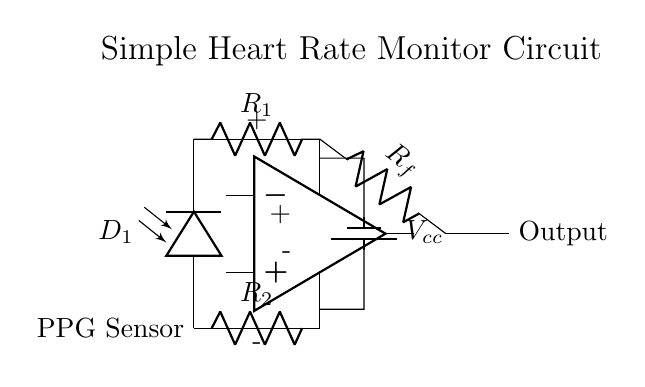What is the type of circuit represented? This is an analog circuit, specifically a heart rate monitor circuit that uses a photoplethysmography sensor and an operational amplifier. Analog circuits are characterized by continuous signal variations, which is suitable for monitoring physiological signals like heart rate.
Answer: analog circuit What component is used for detecting the heart rate? The component used for detecting the heart rate in this circuit is the photoplethysmography sensor (PPG), which is represented as D1 in the diagram. PPG sensors detect changes in light absorption due to blood volume changes in the microvascular bed of tissue.
Answer: PPG sensor What does the output of the circuit represent? The output of the circuit represents the amplified signal corresponding to the heart rate detected by the photoplethysmography sensor. The operational amplifier amplifies this signal for easier analysis or data logging.
Answer: amplified heart rate signal What are the values of the resistors in the circuit? The circuit contains three resistors: R1 connected to the PPG sensor, Rf connected to the op-amp output, and R2 which is connected to the ground. The specific values are not indicated in the diagram, thus they may need to be assigned based on design requirements.
Answer: unspecified values How does the operational amplifier function in this circuit? The operational amplifier in this circuit amplifies the voltage signal generated by the PPG sensor. It receives the input from the PPG sensor via resistor R1 and provides a larger output signal (indicated as "Output") through Rf to be processed or read. This ensures the weak signal from the sensor is usable.
Answer: amplifies signal What is the power supply voltage in this circuit? The power supply voltage in this circuit is denoted as Vcc. The specific voltage value is not provided in the circuit diagram, but for many similar designs, it may commonly be either 5V or 9V depending on the application requirements.
Answer: Vcc What type of diode is used in the circuit? The circuit includes a photodiode, represented as D1, which is used as the sensor detecting light changes due to blood volume fluctuations. Photodiodes convert light into an electrical current, which is crucial for PPG functionality.
Answer: photodiode 